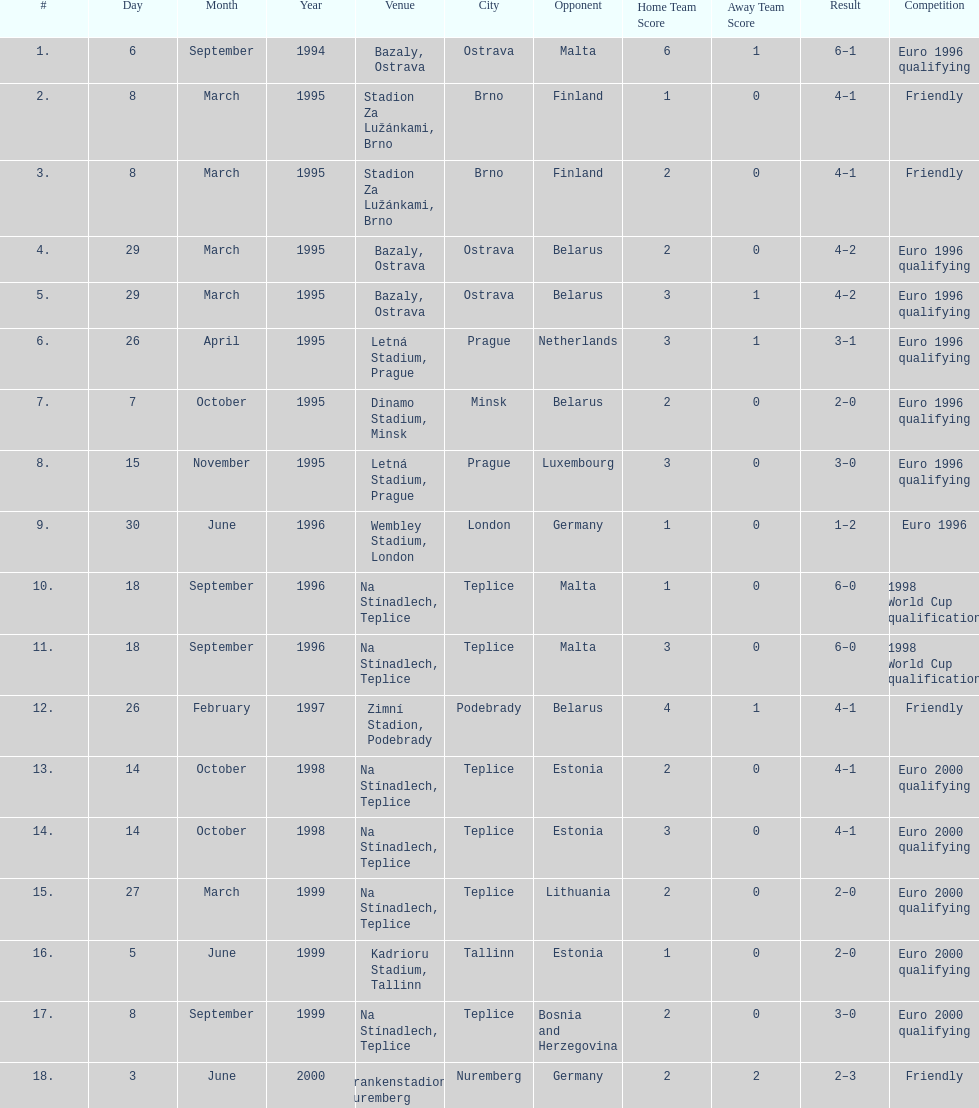What venue is listed above wembley stadium, london? Letná Stadium, Prague. 